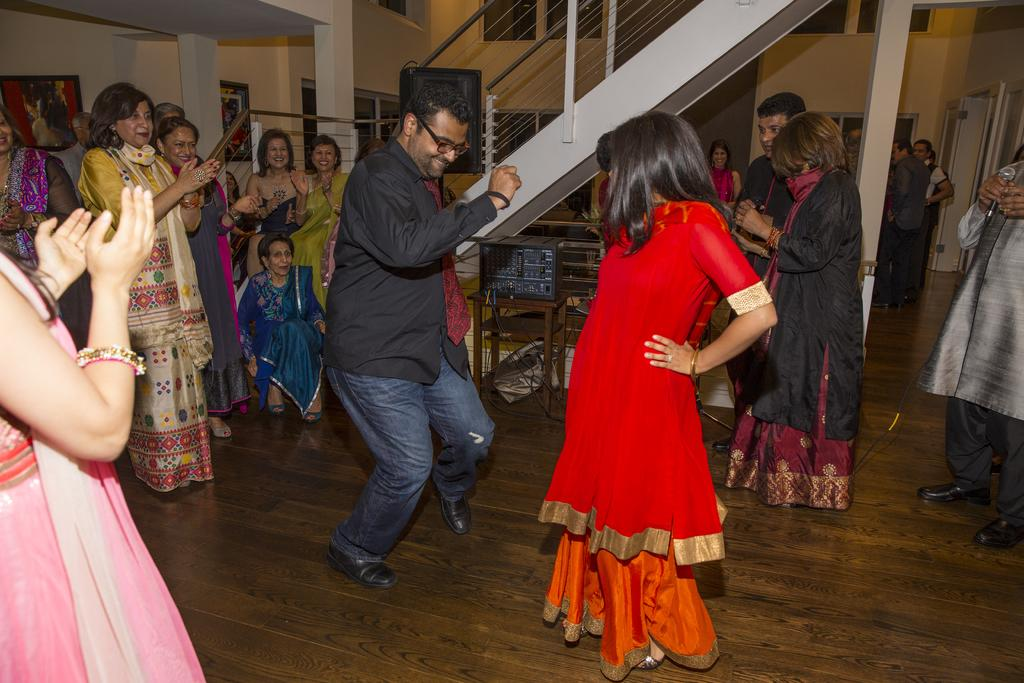What are the persons in the image doing? The persons in the image are dancing. Can you describe the location of the stairs in the image? The stairs are at the top in the image. What is on the right side of the image? There is a door on the right side of the image. How many fingers does the pet have in the image? There is no pet present in the image, so it is not possible to determine the number of fingers it might have. 